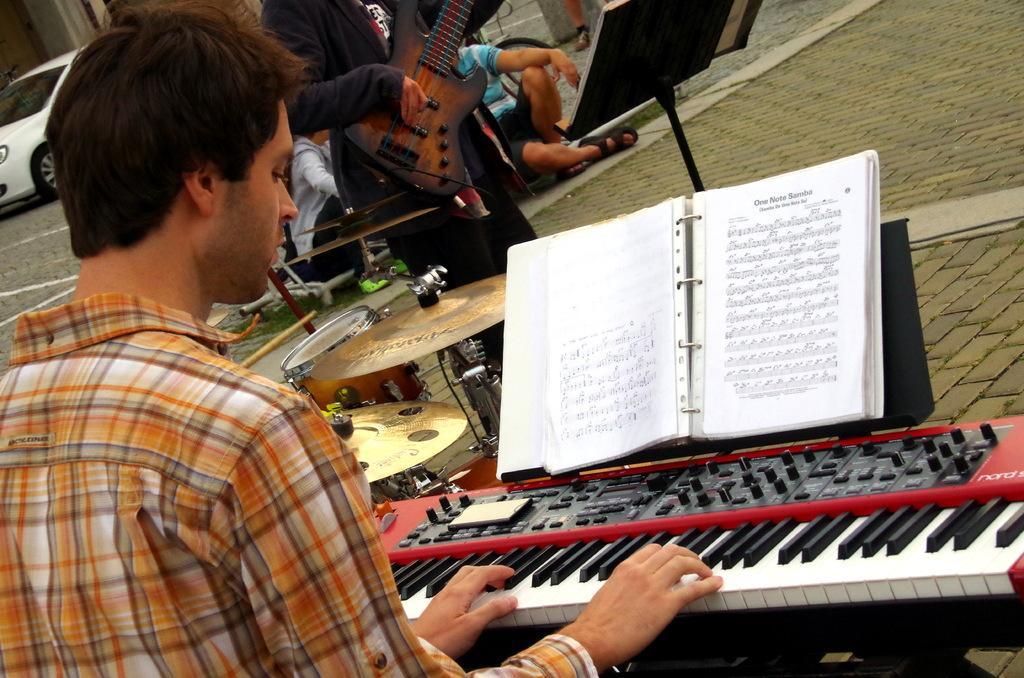In one or two sentences, can you explain what this image depicts? This is the picture on the road. There is a person in the front is playing musical instrument and at the back there is a person standing and playing guitar, in the middle there are drums. At the back there is a car on the road and there are books in front of the persons. 